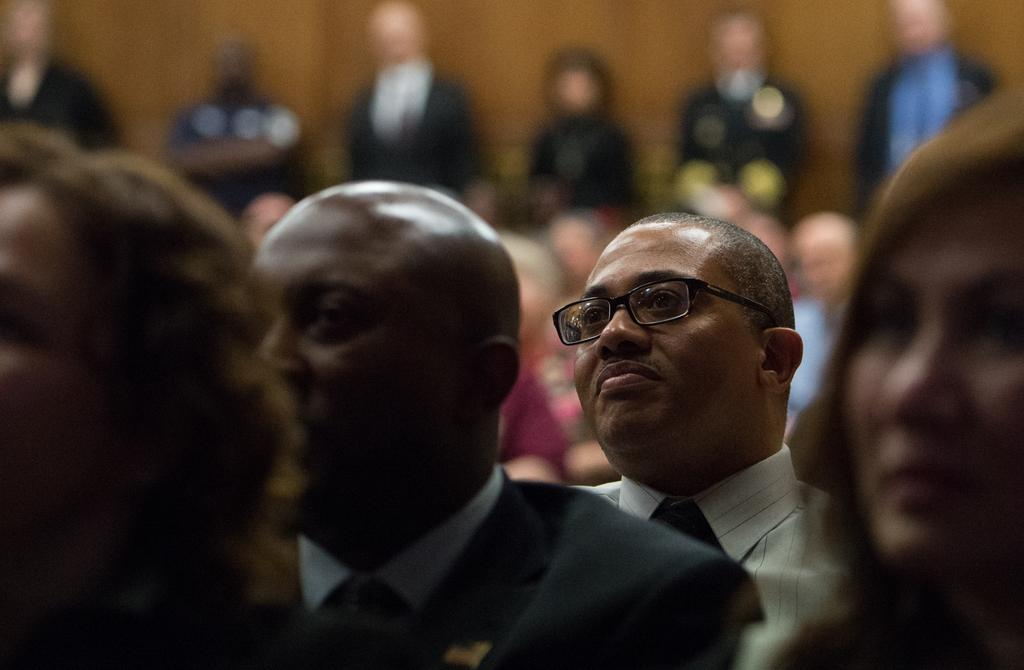How many people are in the image? There are people in the image, but the exact number is not specified. What are some of the people doing in the image? Some of the people are standing in the image. Can you describe the background of the image? The background of the image is blurred. What type of quiver can be seen on the person's back in the image? There is no quiver present in the image. What muscle is being flexed by the person in the image? There is no specific muscle being flexed by a person in the image, as the actions of the people are not described in detail. 